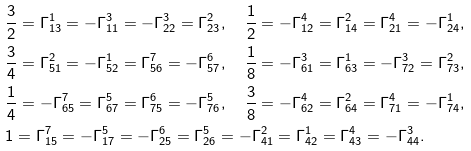<formula> <loc_0><loc_0><loc_500><loc_500>& \frac { 3 } { 2 } = \Gamma _ { 1 3 } ^ { 1 } = - \Gamma _ { 1 1 } ^ { 3 } = - \Gamma _ { 2 2 } ^ { 3 } = \Gamma _ { 2 3 } ^ { 2 } , \quad \frac { 1 } { 2 } = - \Gamma _ { 1 2 } ^ { 4 } = \Gamma _ { 1 4 } ^ { 2 } = \Gamma _ { 2 1 } ^ { 4 } = - \Gamma _ { 2 4 } ^ { 1 } , \\ & \frac { 3 } { 4 } = \Gamma _ { 5 1 } ^ { 2 } = - \Gamma _ { 5 2 } ^ { 1 } = \Gamma _ { 5 6 } ^ { 7 } = - \Gamma _ { 5 7 } ^ { 6 } , \quad \frac { 1 } { 8 } = - \Gamma _ { 6 1 } ^ { 3 } = \Gamma _ { 6 3 } ^ { 1 } = - \Gamma _ { 7 2 } ^ { 3 } = \Gamma _ { 7 3 } ^ { 2 } , \\ & \frac { 1 } { 4 } = - \Gamma _ { 6 5 } ^ { 7 } = \Gamma _ { 6 7 } ^ { 5 } = \Gamma _ { 7 5 } ^ { 6 } = - \Gamma _ { 7 6 } ^ { 5 } , \quad \frac { 3 } { 8 } = - \Gamma _ { 6 2 } ^ { 4 } = \Gamma _ { 6 4 } ^ { 2 } = \Gamma _ { 7 1 } ^ { 4 } = - \Gamma _ { 7 4 } ^ { 1 } , \\ & 1 = \Gamma _ { 1 5 } ^ { 7 } = - \Gamma _ { 1 7 } ^ { 5 } = - \Gamma _ { 2 5 } ^ { 6 } = \Gamma _ { 2 6 } ^ { 5 } = - \Gamma _ { 4 1 } ^ { 2 } = \Gamma _ { 4 2 } ^ { 1 } = \Gamma _ { 4 3 } ^ { 4 } = - \Gamma _ { 4 4 } ^ { 3 } .</formula> 